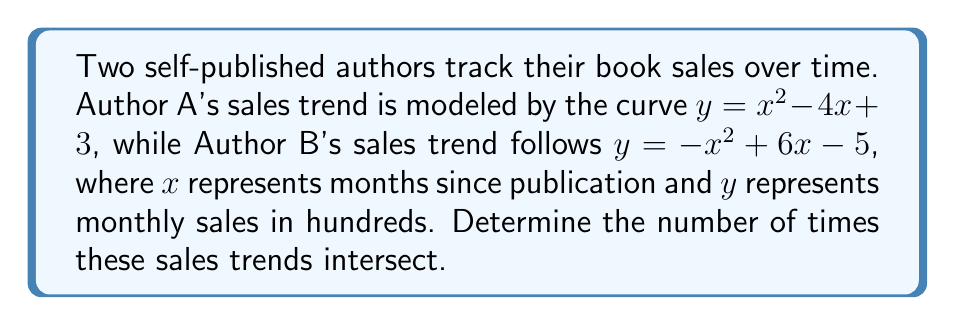Help me with this question. To find the number of intersections between these two algebraic curves, we need to solve the equation formed by setting the two functions equal to each other:

$$x^2 - 4x + 3 = -x^2 + 6x - 5$$

Step 1: Rearrange the equation to standard form.
$$x^2 - 4x + 3 + x^2 - 6x + 5 = 0$$
$$2x^2 - 10x + 8 = 0$$

Step 2: Divide all terms by 2 to simplify.
$$x^2 - 5x + 4 = 0$$

Step 3: This is a quadratic equation. We can solve it using the quadratic formula:
$$x = \frac{-b \pm \sqrt{b^2 - 4ac}}{2a}$$
Where $a=1$, $b=-5$, and $c=4$

Step 4: Substitute these values into the quadratic formula.
$$x = \frac{5 \pm \sqrt{25 - 16}}{2} = \frac{5 \pm 3}{2}$$

Step 5: Solve for the two roots.
$$x_1 = \frac{5 + 3}{2} = 4$$
$$x_2 = \frac{5 - 3}{2} = 1$$

The existence of two distinct real roots indicates that the curves intersect at two points.
Answer: 2 